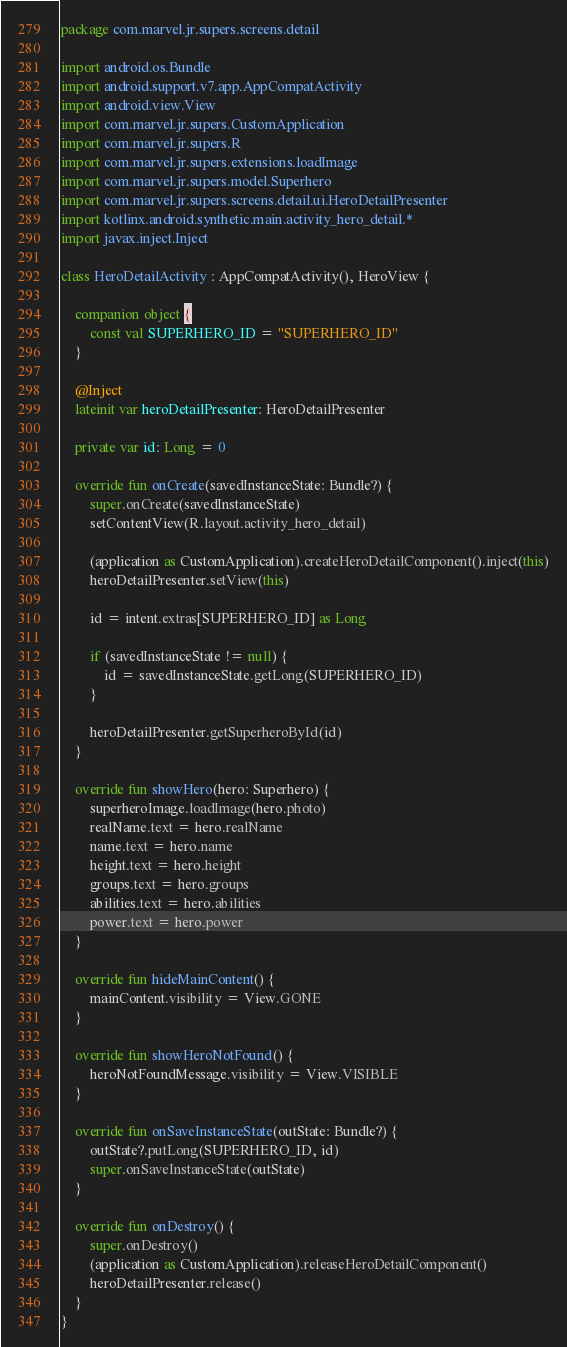Convert code to text. <code><loc_0><loc_0><loc_500><loc_500><_Kotlin_>package com.marvel.jr.supers.screens.detail

import android.os.Bundle
import android.support.v7.app.AppCompatActivity
import android.view.View
import com.marvel.jr.supers.CustomApplication
import com.marvel.jr.supers.R
import com.marvel.jr.supers.extensions.loadImage
import com.marvel.jr.supers.model.Superhero
import com.marvel.jr.supers.screens.detail.ui.HeroDetailPresenter
import kotlinx.android.synthetic.main.activity_hero_detail.*
import javax.inject.Inject

class HeroDetailActivity : AppCompatActivity(), HeroView {

    companion object {
        const val SUPERHERO_ID = "SUPERHERO_ID"
    }

    @Inject
    lateinit var heroDetailPresenter: HeroDetailPresenter

    private var id: Long = 0

    override fun onCreate(savedInstanceState: Bundle?) {
        super.onCreate(savedInstanceState)
        setContentView(R.layout.activity_hero_detail)

        (application as CustomApplication).createHeroDetailComponent().inject(this)
        heroDetailPresenter.setView(this)

        id = intent.extras[SUPERHERO_ID] as Long

        if (savedInstanceState != null) {
            id = savedInstanceState.getLong(SUPERHERO_ID)
        }

        heroDetailPresenter.getSuperheroById(id)
    }

    override fun showHero(hero: Superhero) {
        superheroImage.loadImage(hero.photo)
        realName.text = hero.realName
        name.text = hero.name
        height.text = hero.height
        groups.text = hero.groups
        abilities.text = hero.abilities
        power.text = hero.power
    }

    override fun hideMainContent() {
        mainContent.visibility = View.GONE
    }

    override fun showHeroNotFound() {
        heroNotFoundMessage.visibility = View.VISIBLE
    }

    override fun onSaveInstanceState(outState: Bundle?) {
        outState?.putLong(SUPERHERO_ID, id)
        super.onSaveInstanceState(outState)
    }

    override fun onDestroy() {
        super.onDestroy()
        (application as CustomApplication).releaseHeroDetailComponent()
        heroDetailPresenter.release()
    }
}
</code> 